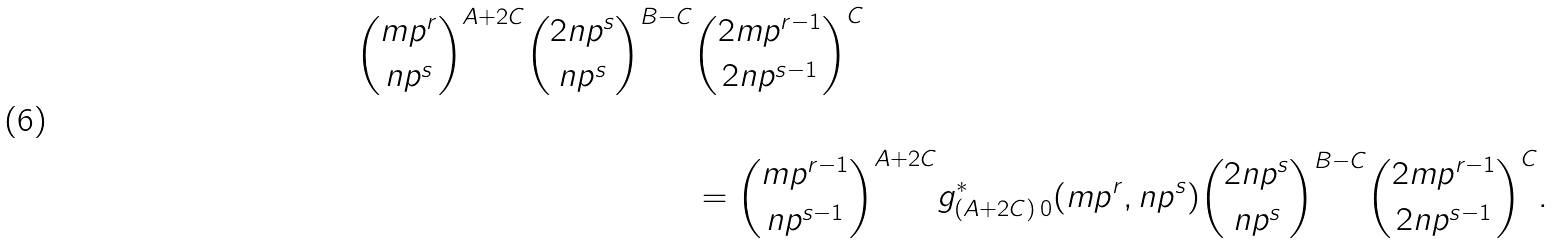Convert formula to latex. <formula><loc_0><loc_0><loc_500><loc_500>\binom { m p ^ { r } } { n p ^ { s } } ^ { A + 2 C } \binom { 2 n p ^ { s } } { n p ^ { s } } ^ { B - C } & \binom { 2 m p ^ { r - 1 } } { 2 n p ^ { s - 1 } } ^ { C } \\ & \\ & = \binom { m p ^ { r - 1 } } { n p ^ { s - 1 } } ^ { A + 2 C } g _ { ( A + 2 C ) \, 0 } ^ { * } ( m p ^ { r } , n p ^ { s } ) \binom { 2 n p ^ { s } } { n p ^ { s } } ^ { B - C } \binom { 2 m p ^ { r - 1 } } { 2 n p ^ { s - 1 } } ^ { C } .</formula> 